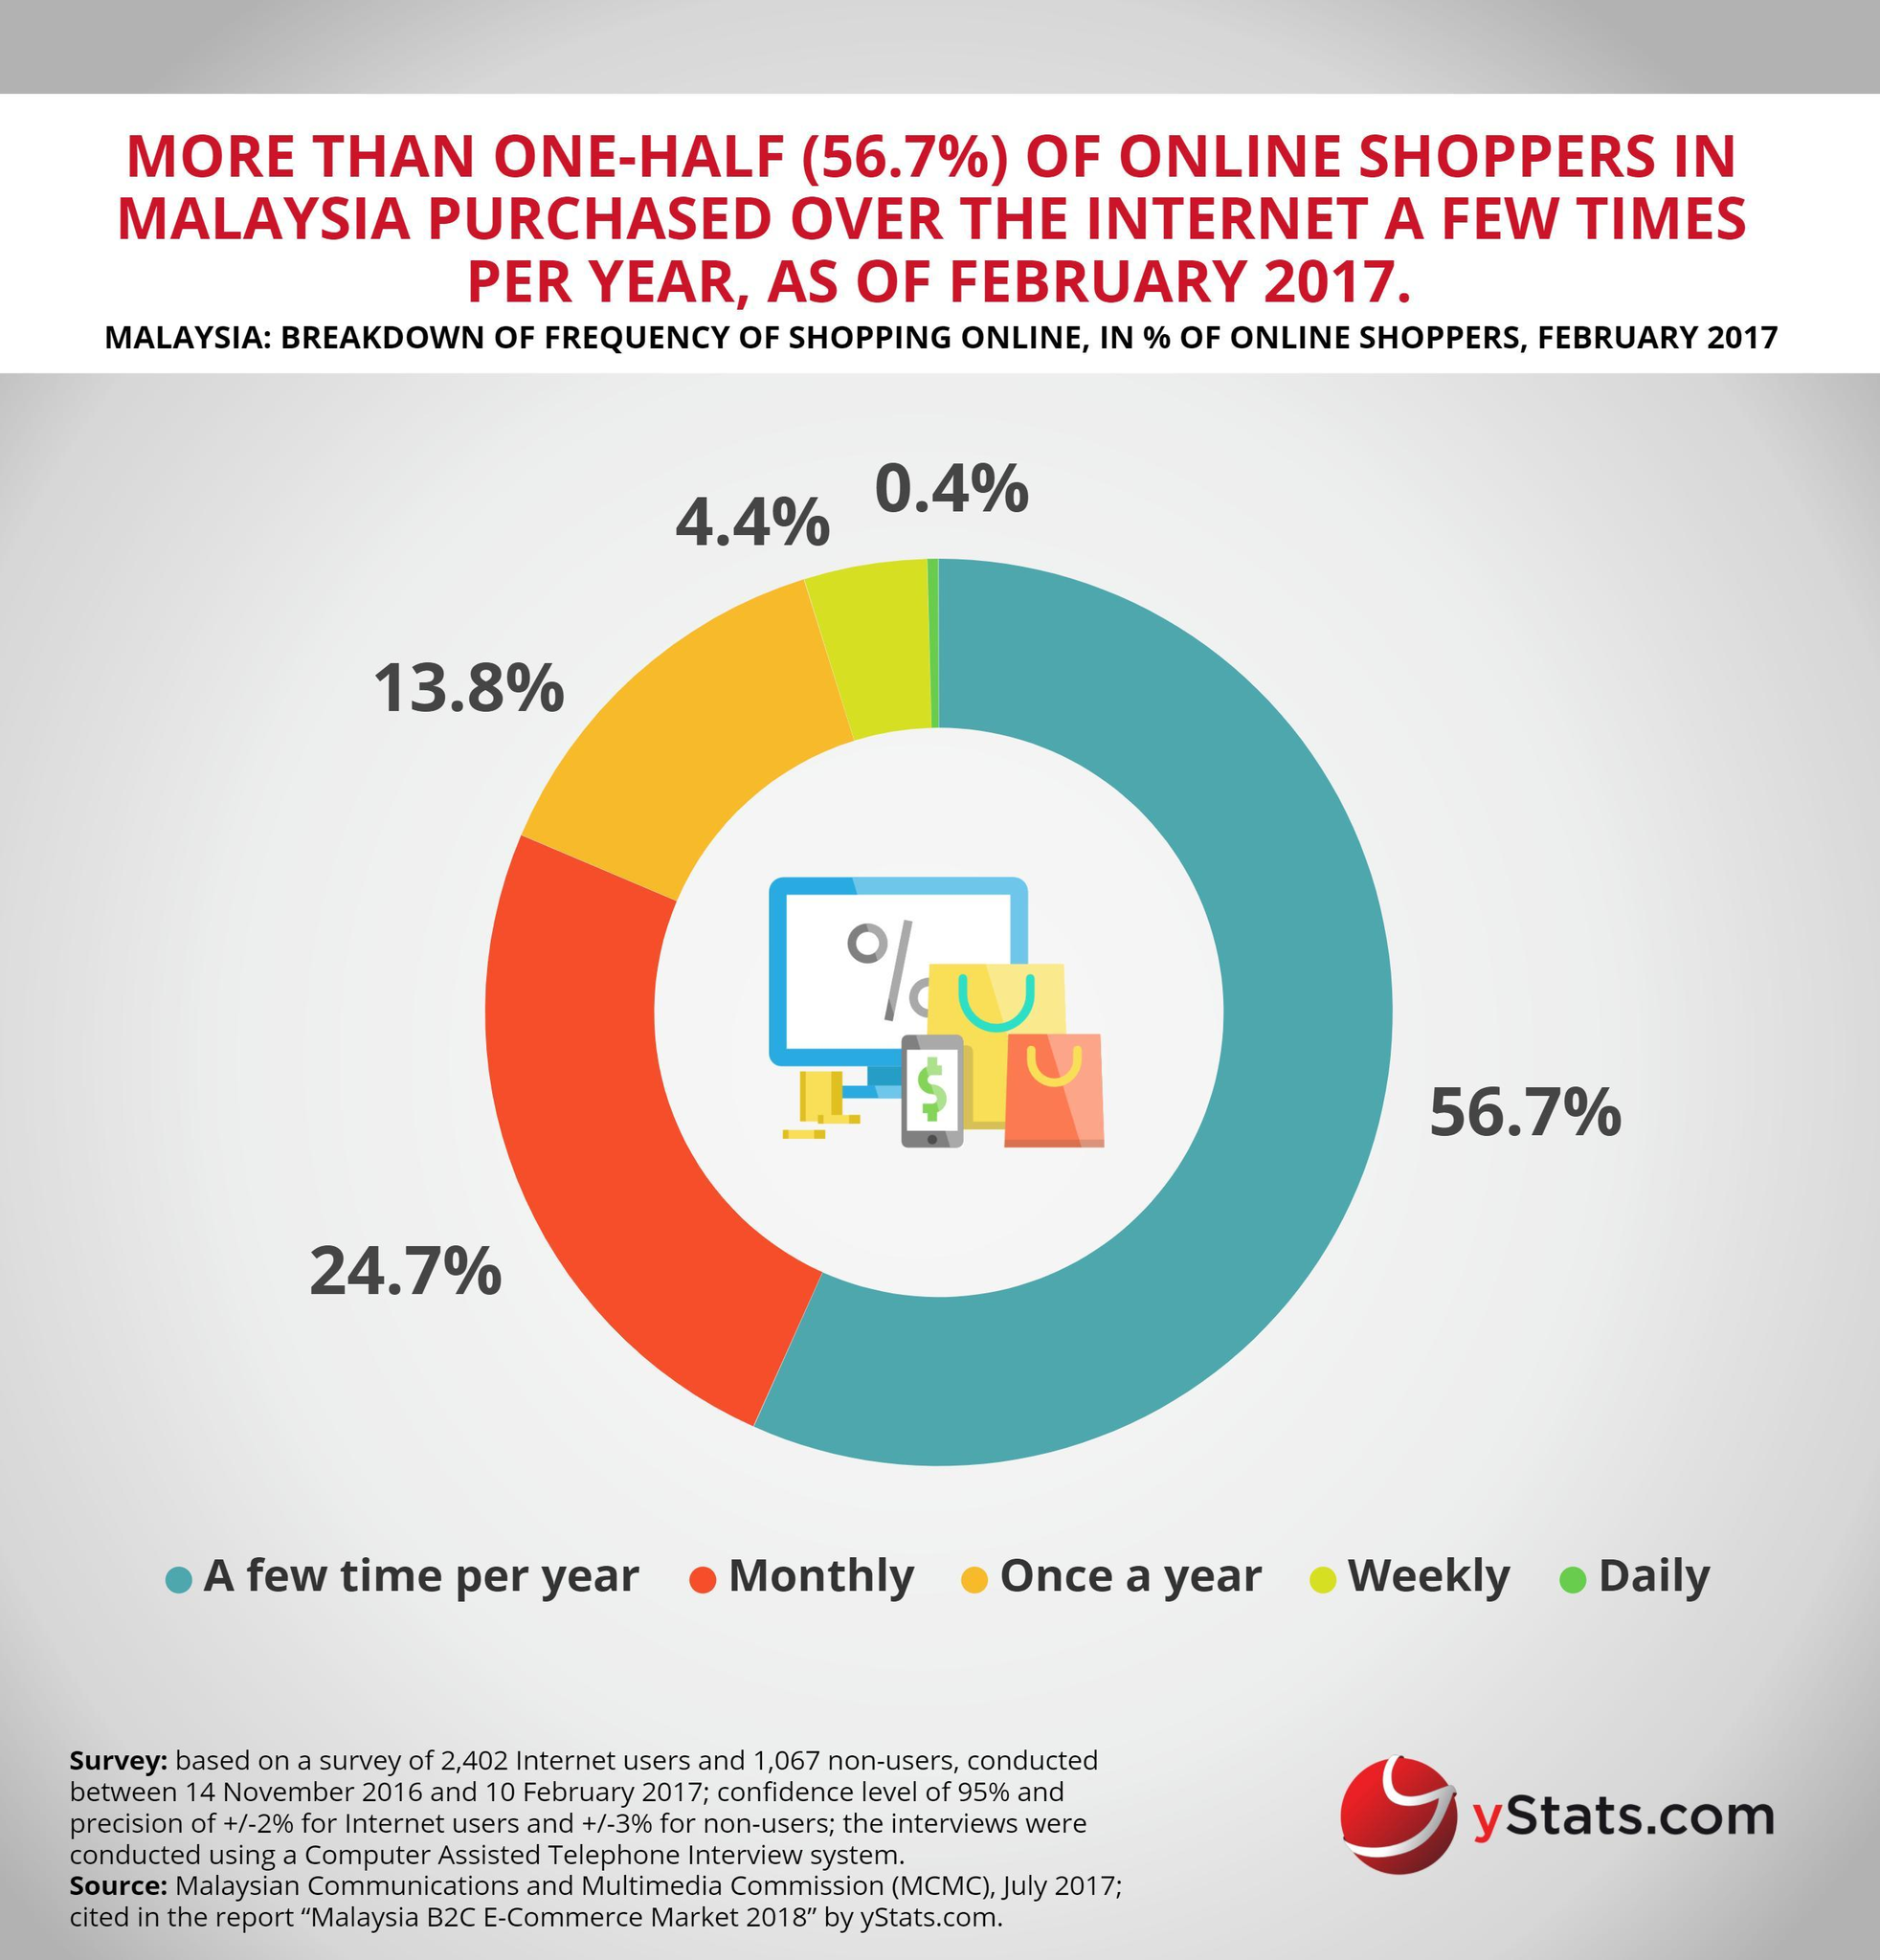What percentage of Malaysian users do not shop online a few times per year?
Answer the question with a short phrase. 43.3 How many different types of Online shopping methods are listed in the info graphic? 5 Which type of online shoppers has the third highest position in the frequency of online shopping? Once a year Which type of online shoppers has the second highest position in the frequency of online shopping? Monthly What percentage of Malaysian users shops online on weekly basis? 4.4% What percentage of Malaysian users shops online on Yearly basis? 13.8% What percentage of Malaysian people do not shop online on daily basis? 99.6 What is the percentage of users who shops online on monthly basis? 24.7% 